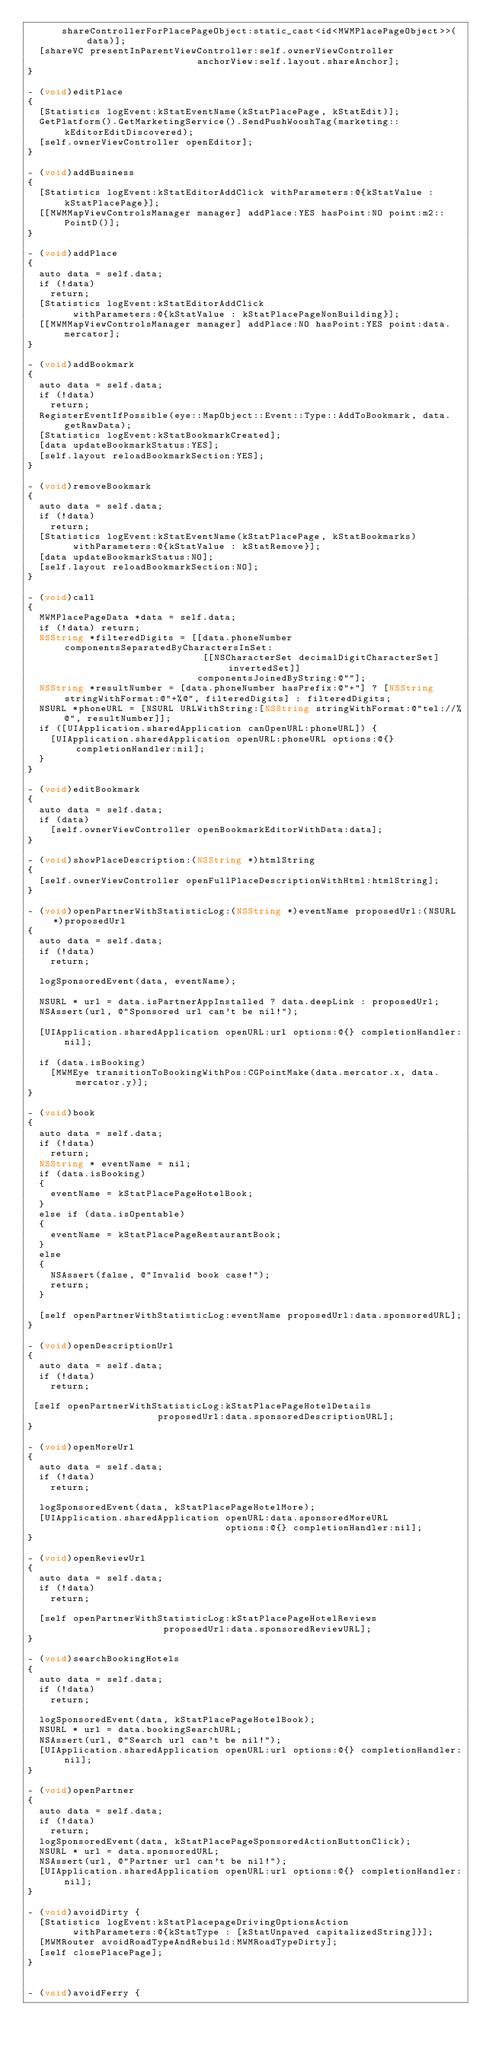<code> <loc_0><loc_0><loc_500><loc_500><_ObjectiveC_>      shareControllerForPlacePageObject:static_cast<id<MWMPlacePageObject>>(data)];
  [shareVC presentInParentViewController:self.ownerViewController
                              anchorView:self.layout.shareAnchor];
}

- (void)editPlace
{
  [Statistics logEvent:kStatEventName(kStatPlacePage, kStatEdit)];
  GetPlatform().GetMarketingService().SendPushWooshTag(marketing::kEditorEditDiscovered);
  [self.ownerViewController openEditor];
}

- (void)addBusiness
{
  [Statistics logEvent:kStatEditorAddClick withParameters:@{kStatValue : kStatPlacePage}];
  [[MWMMapViewControlsManager manager] addPlace:YES hasPoint:NO point:m2::PointD()];
}

- (void)addPlace
{
  auto data = self.data;
  if (!data)
    return;
  [Statistics logEvent:kStatEditorAddClick
        withParameters:@{kStatValue : kStatPlacePageNonBuilding}];
  [[MWMMapViewControlsManager manager] addPlace:NO hasPoint:YES point:data.mercator];
}

- (void)addBookmark
{
  auto data = self.data;
  if (!data)
    return;
  RegisterEventIfPossible(eye::MapObject::Event::Type::AddToBookmark, data.getRawData);
  [Statistics logEvent:kStatBookmarkCreated];
  [data updateBookmarkStatus:YES];
  [self.layout reloadBookmarkSection:YES];
}

- (void)removeBookmark
{
  auto data = self.data;
  if (!data)
    return;
  [Statistics logEvent:kStatEventName(kStatPlacePage, kStatBookmarks)
        withParameters:@{kStatValue : kStatRemove}];
  [data updateBookmarkStatus:NO];
  [self.layout reloadBookmarkSection:NO];
}

- (void)call
{
  MWMPlacePageData *data = self.data;
  if (!data) return;
  NSString *filteredDigits = [[data.phoneNumber componentsSeparatedByCharactersInSet:
                               [[NSCharacterSet decimalDigitCharacterSet] invertedSet]]
                              componentsJoinedByString:@""];
  NSString *resultNumber = [data.phoneNumber hasPrefix:@"+"] ? [NSString stringWithFormat:@"+%@", filteredDigits] : filteredDigits;
  NSURL *phoneURL = [NSURL URLWithString:[NSString stringWithFormat:@"tel://%@", resultNumber]];
  if ([UIApplication.sharedApplication canOpenURL:phoneURL]) {
    [UIApplication.sharedApplication openURL:phoneURL options:@{} completionHandler:nil];
  }
}

- (void)editBookmark
{
  auto data = self.data;
  if (data)
    [self.ownerViewController openBookmarkEditorWithData:data];
}

- (void)showPlaceDescription:(NSString *)htmlString
{
  [self.ownerViewController openFullPlaceDescriptionWithHtml:htmlString];
}

- (void)openPartnerWithStatisticLog:(NSString *)eventName proposedUrl:(NSURL *)proposedUrl
{
  auto data = self.data;
  if (!data)
    return;
  
  logSponsoredEvent(data, eventName);
  
  NSURL * url = data.isPartnerAppInstalled ? data.deepLink : proposedUrl;
  NSAssert(url, @"Sponsored url can't be nil!");
  
  [UIApplication.sharedApplication openURL:url options:@{} completionHandler:nil];

  if (data.isBooking)
    [MWMEye transitionToBookingWithPos:CGPointMake(data.mercator.x, data.mercator.y)];
}

- (void)book
{
  auto data = self.data;
  if (!data)
    return;
  NSString * eventName = nil;
  if (data.isBooking)
  {
    eventName = kStatPlacePageHotelBook;
  }
  else if (data.isOpentable)
  {
    eventName = kStatPlacePageRestaurantBook;
  }
  else
  {
    NSAssert(false, @"Invalid book case!");
    return;
  }
  
  [self openPartnerWithStatisticLog:eventName proposedUrl:data.sponsoredURL];
}

- (void)openDescriptionUrl
{
  auto data = self.data;
  if (!data)
    return;
 
 [self openPartnerWithStatisticLog:kStatPlacePageHotelDetails
                       proposedUrl:data.sponsoredDescriptionURL];
}

- (void)openMoreUrl
{
  auto data = self.data;
  if (!data)
    return;

  logSponsoredEvent(data, kStatPlacePageHotelMore);
  [UIApplication.sharedApplication openURL:data.sponsoredMoreURL
                                   options:@{} completionHandler:nil];
}

- (void)openReviewUrl
{
  auto data = self.data;
  if (!data)
    return;
  
  [self openPartnerWithStatisticLog:kStatPlacePageHotelReviews
                        proposedUrl:data.sponsoredReviewURL];
}

- (void)searchBookingHotels
{
  auto data = self.data;
  if (!data)
    return;
  
  logSponsoredEvent(data, kStatPlacePageHotelBook);
  NSURL * url = data.bookingSearchURL;
  NSAssert(url, @"Search url can't be nil!");
  [UIApplication.sharedApplication openURL:url options:@{} completionHandler:nil];
}

- (void)openPartner
{
  auto data = self.data;
  if (!data)
    return;
  logSponsoredEvent(data, kStatPlacePageSponsoredActionButtonClick);
  NSURL * url = data.sponsoredURL;
  NSAssert(url, @"Partner url can't be nil!");
  [UIApplication.sharedApplication openURL:url options:@{} completionHandler:nil];
}

- (void)avoidDirty {
  [Statistics logEvent:kStatPlacepageDrivingOptionsAction
        withParameters:@{kStatType : [kStatUnpaved capitalizedString]}];
  [MWMRouter avoidRoadTypeAndRebuild:MWMRoadTypeDirty];
  [self closePlacePage];
}


- (void)avoidFerry {</code> 